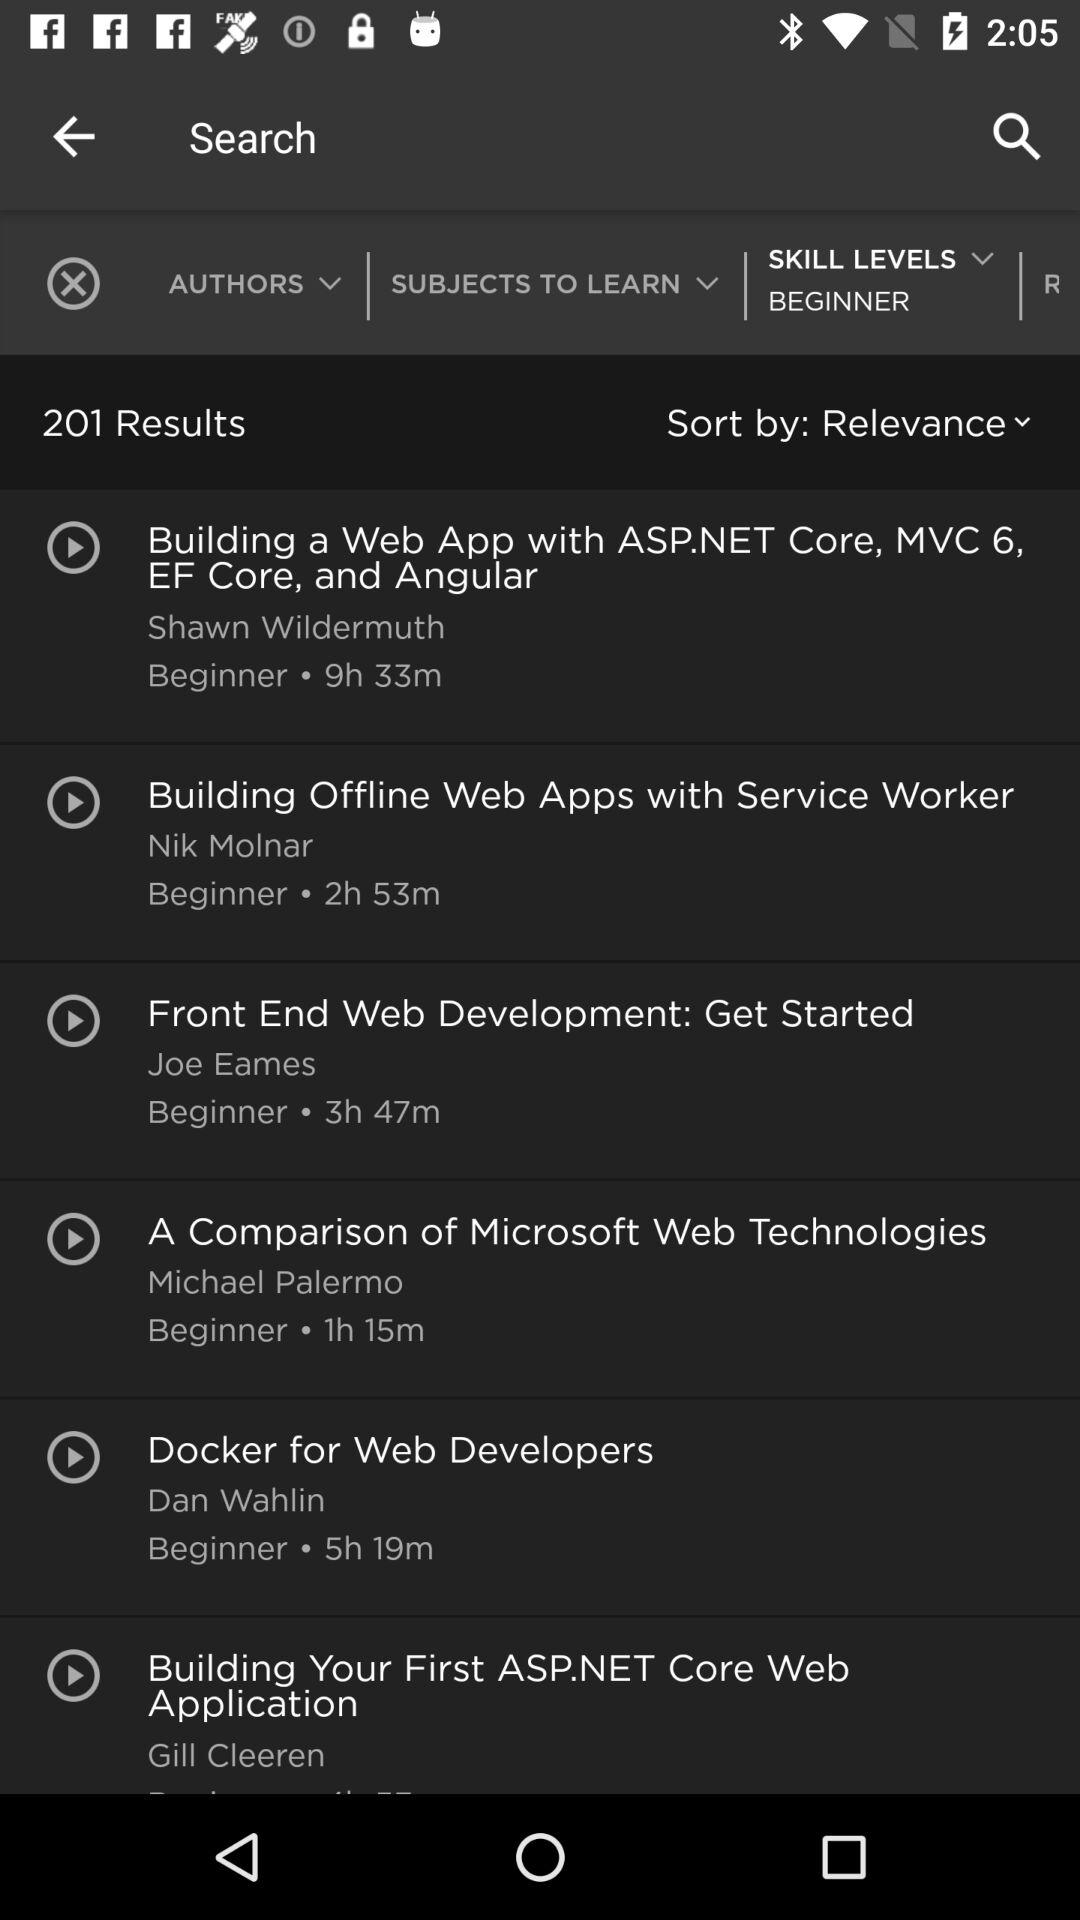What is the duration of the video whose author is Joe Eames? The duration of the video is 3 hours and 47 minutes. 